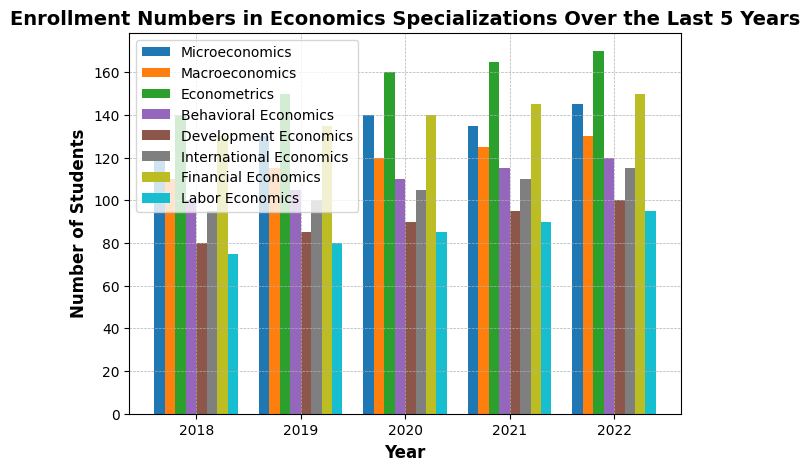What year had the highest enrollment in Econometrics? By observing the height of the bars corresponding to Econometrics, the tallest bar indicates the highest enrollment year. The color representing Econometrics is consistent across all years. The tallest bar occurs in 2022.
Answer: 2022 Which specialization had a higher increase in enrollment from 2018 to 2022: Macroeconomics or Behavioral Economics? To determine this, we calculate the difference in enrollment numbers between 2022 and 2018 for both specializations. Macroeconomics went from 110 to 130, increasing by 20. Behavioral Economics went from 100 to 120, increasing by 20. Both specializations had the same increase.
Answer: Both had the same increase What is the average enrollment number in Financial Economics over the 5-year period? Summing the enrollment numbers for Financial Economics over the 5 years (130, 135, 140, 145, and 150) gives 700. Dividing this sum by 5 gives the average: 700 / 5.
Answer: 140 Which specialization had the lowest enrollment in any given year? To find this, examine all the bars and identify the shortest one. The year 2018 for Development Economics, represented by the shortest bar, indicates the lowest enrollment number, which is 80.
Answer: Development Economics in 2018 How did the enrollment in Development Economics change from 2018 to 2022? Observing the bars for Development Economics, we see the bar increases in height from 80 in 2018 to 100 in 2022. The increase is calculated as 100 - 80.
Answer: Increased by 20 Between which consecutive years did Labor Economics see the highest increase in enrollment? By examining the bars for Labor Economics, we can see the year-on-year changes: 75 to 80 (2018-2019), 80 to 85 (2019-2020), 85 to 90 (2020-2021), and 90 to 95 (2021-2022). The highest increase occurred between 2020 and 2021 (5).
Answer: 2020 to 2021 What is the cumulative enrollment for all specializations in 2020? Sum the enrollment numbers for all specializations in 2020: 140 (Microeconomics) + 120 (Macroeconomics) + 160 (Econometrics) + 110 (Behavioral Economics) + 90 (Development Economics) + 105 (International Economics) + 140 (Financial Economics) + 85 (Labor Economics). The total is 950.
Answer: 950 Which specialization consistently grew in enrollment over the 5 years? Observing the bar heights across all years for each specialization, all specializations show consistent growth.
Answer: All specializations Which two specializations had the closest enrollment numbers in 2019? By comparing the height of the bars, we notice that Behavioral Economics (105) and Development Economics (85) have a difference of 20, and other bars have larger differences.
Answer: Behavioral Economics and Development Economics 